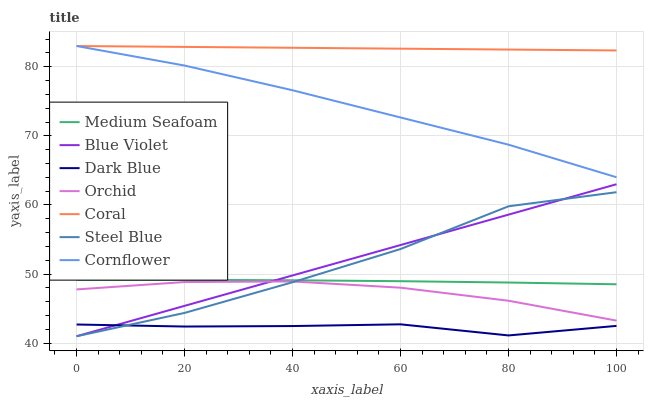Does Dark Blue have the minimum area under the curve?
Answer yes or no. Yes. Does Coral have the maximum area under the curve?
Answer yes or no. Yes. Does Steel Blue have the minimum area under the curve?
Answer yes or no. No. Does Steel Blue have the maximum area under the curve?
Answer yes or no. No. Is Coral the smoothest?
Answer yes or no. Yes. Is Steel Blue the roughest?
Answer yes or no. Yes. Is Steel Blue the smoothest?
Answer yes or no. No. Is Coral the roughest?
Answer yes or no. No. Does Steel Blue have the lowest value?
Answer yes or no. Yes. Does Coral have the lowest value?
Answer yes or no. No. Does Coral have the highest value?
Answer yes or no. Yes. Does Steel Blue have the highest value?
Answer yes or no. No. Is Steel Blue less than Coral?
Answer yes or no. Yes. Is Medium Seafoam greater than Orchid?
Answer yes or no. Yes. Does Blue Violet intersect Dark Blue?
Answer yes or no. Yes. Is Blue Violet less than Dark Blue?
Answer yes or no. No. Is Blue Violet greater than Dark Blue?
Answer yes or no. No. Does Steel Blue intersect Coral?
Answer yes or no. No. 